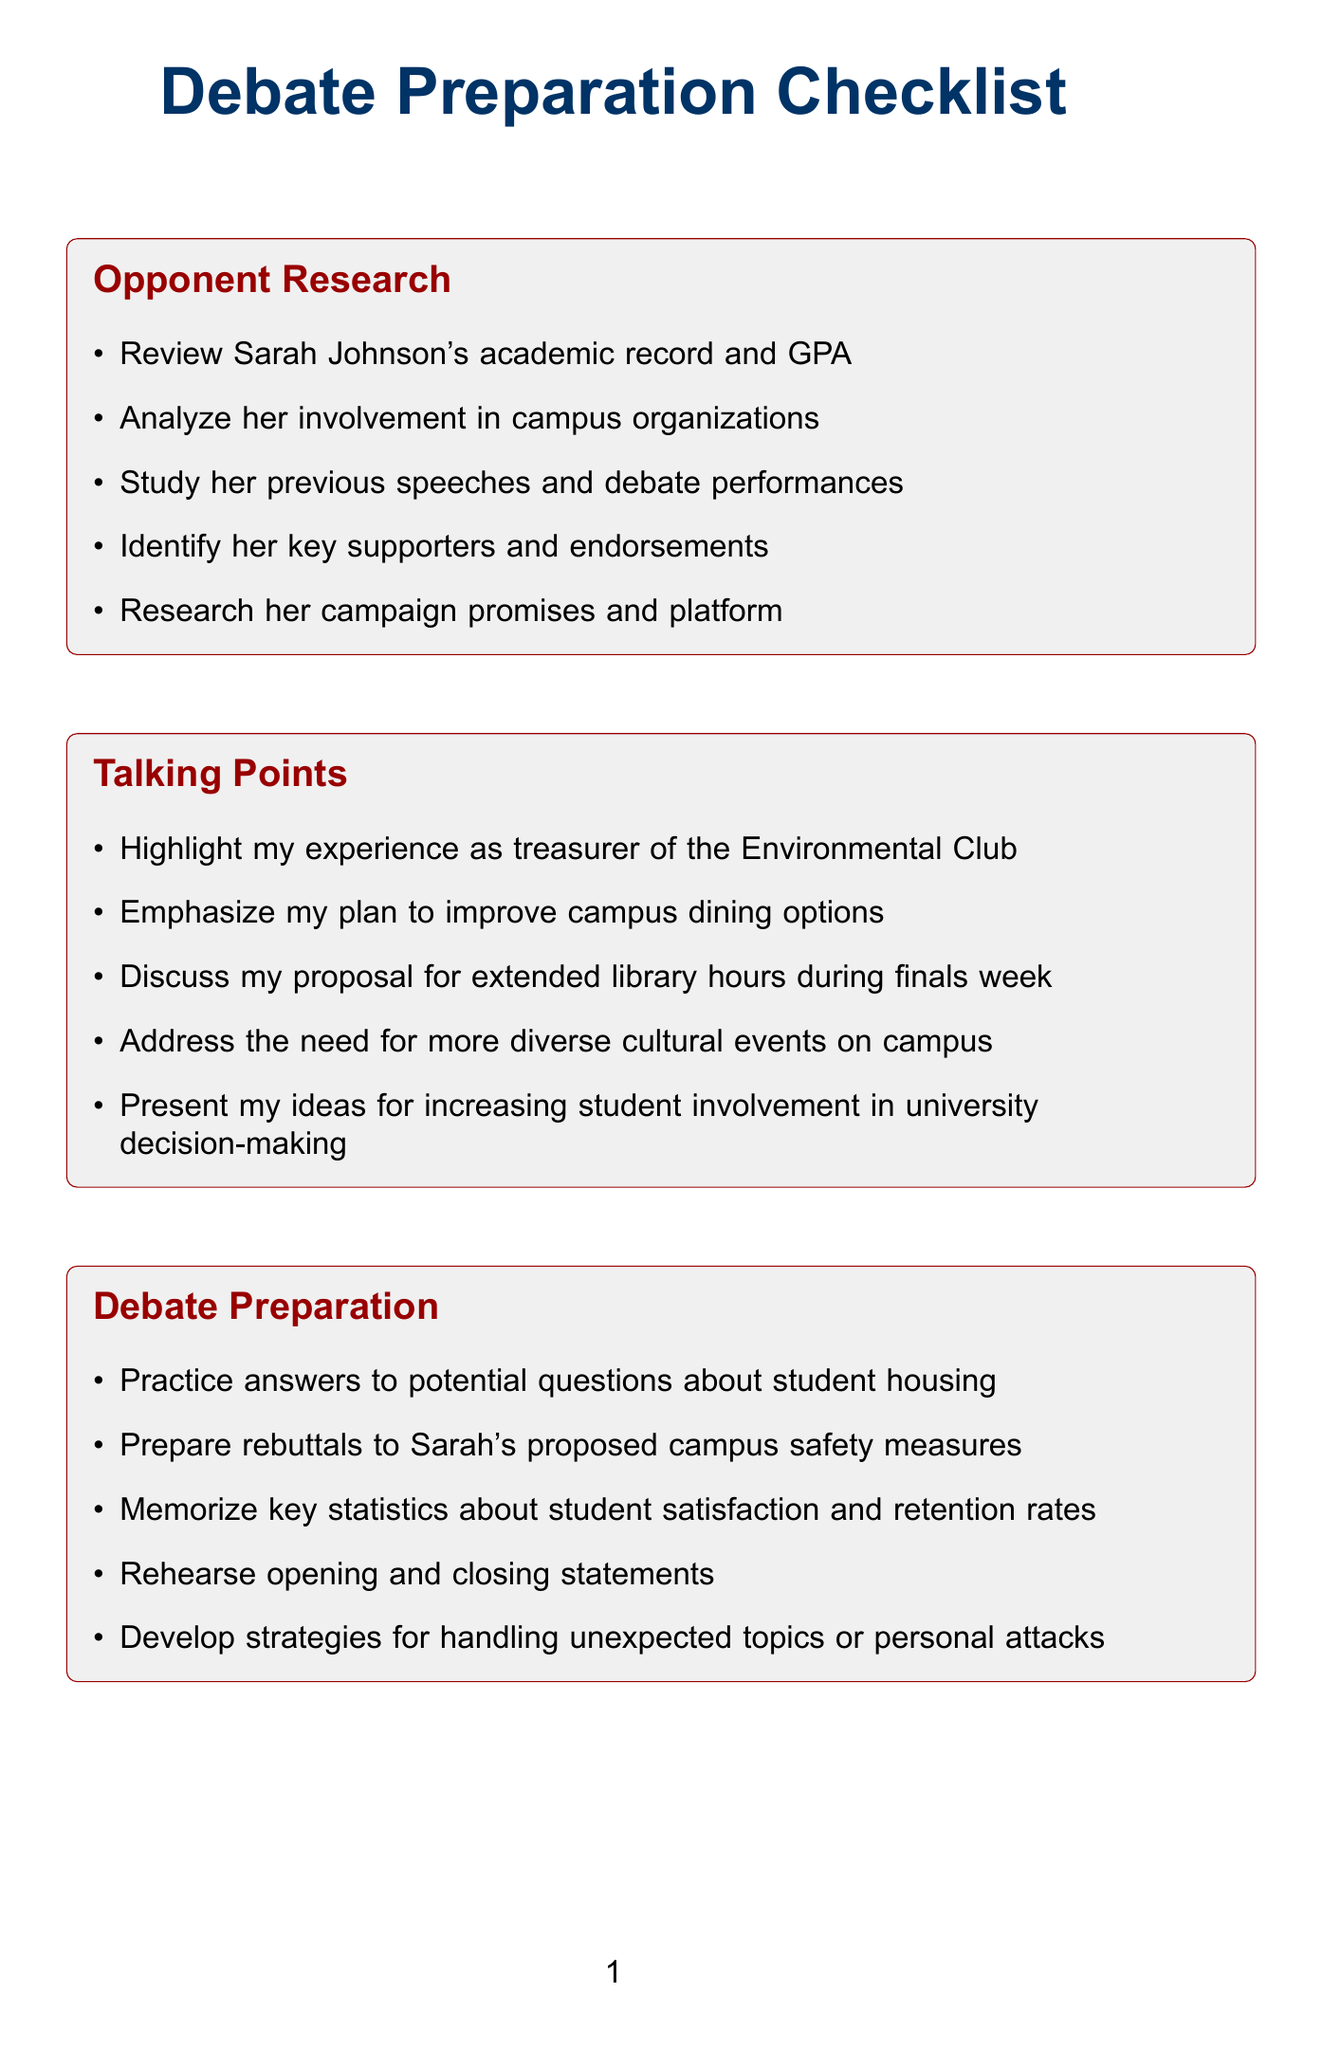What are Sarah Johnson's key supporters? Identifying key supporters is crucial for understanding her backing in the debate context.
Answer: key supporters What is one proposed campus safety measure from Sarah? Understanding her measures helps formulate rebuttals and comparisons.
Answer: campus safety measures How many talking points are listed in the document? Counting the talking points gives an overview of the areas covered in argumentation.
Answer: five What is the first item listed under Audience Engagement? Knowing the first engagement strategy helps in preparing for audience interaction.
Answer: Prepare relatable anecdotes about student life challenges What is one topic I should prepare rebuttals for? Knowing this helps in strategizing responses to opponent arguments.
Answer: Sarah's proposed campus safety measures What is the category that includes improvements for campus dining options? This helps identify key focus areas for my campaign messaging.
Answer: Talking Points Which category discusses policy comparison? Identifying this category helps to understand the focus on policy differences.
Answer: Policy Comparison 